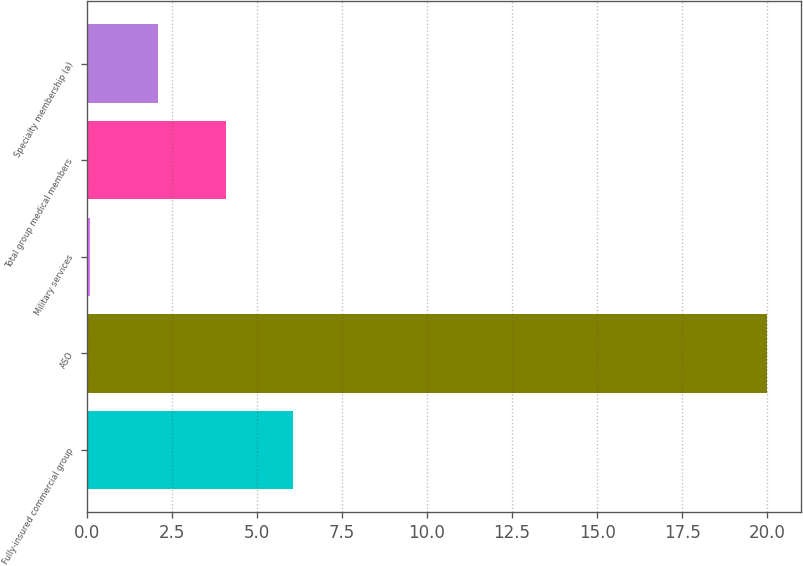Convert chart to OTSL. <chart><loc_0><loc_0><loc_500><loc_500><bar_chart><fcel>Fully-insured commercial group<fcel>ASO<fcel>Military services<fcel>Total group medical members<fcel>Specialty membership (a)<nl><fcel>6.07<fcel>20<fcel>0.1<fcel>4.08<fcel>2.09<nl></chart> 